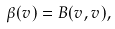<formula> <loc_0><loc_0><loc_500><loc_500>\beta ( v ) = B ( v , v ) ,</formula> 